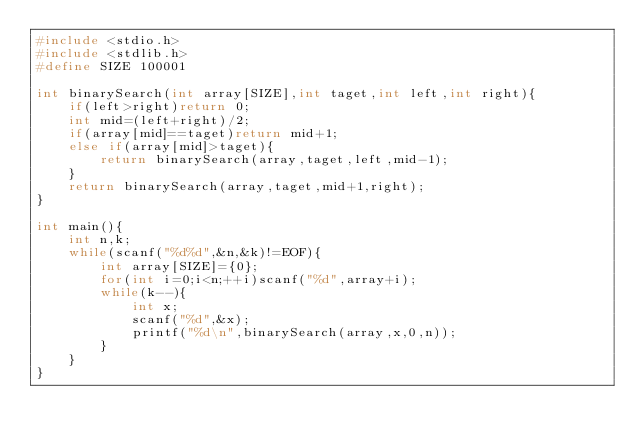Convert code to text. <code><loc_0><loc_0><loc_500><loc_500><_C_>#include <stdio.h>
#include <stdlib.h>
#define SIZE 100001

int binarySearch(int array[SIZE],int taget,int left,int right){
    if(left>right)return 0;
    int mid=(left+right)/2;
    if(array[mid]==taget)return mid+1;
    else if(array[mid]>taget){
        return binarySearch(array,taget,left,mid-1);
    }
    return binarySearch(array,taget,mid+1,right);
}

int main(){
    int n,k;
    while(scanf("%d%d",&n,&k)!=EOF){
        int array[SIZE]={0};
        for(int i=0;i<n;++i)scanf("%d",array+i);
        while(k--){
            int x;
            scanf("%d",&x);
            printf("%d\n",binarySearch(array,x,0,n));
        }
    }
}
</code> 